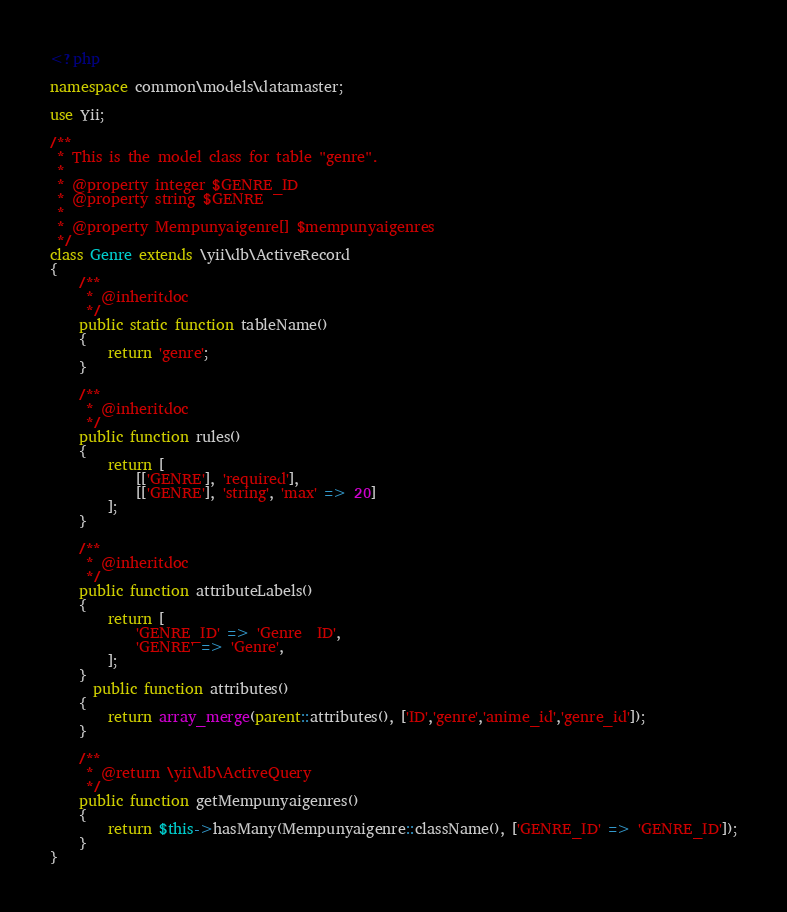Convert code to text. <code><loc_0><loc_0><loc_500><loc_500><_PHP_><?php

namespace common\models\datamaster;

use Yii;

/**
 * This is the model class for table "genre".
 *
 * @property integer $GENRE_ID
 * @property string $GENRE
 *
 * @property Mempunyaigenre[] $mempunyaigenres
 */
class Genre extends \yii\db\ActiveRecord
{
    /**
     * @inheritdoc
     */
    public static function tableName()
    {
        return 'genre';
    }

    /**
     * @inheritdoc
     */
    public function rules()
    {
        return [
            [['GENRE'], 'required'],
            [['GENRE'], 'string', 'max' => 20]
        ];
    }

    /**
     * @inheritdoc
     */
    public function attributeLabels()
    {
        return [
            'GENRE_ID' => 'Genre  ID',
            'GENRE' => 'Genre',
        ];
    }
      public function attributes()
    {
        return array_merge(parent::attributes(), ['ID','genre','anime_id','genre_id']);
    }

    /**
     * @return \yii\db\ActiveQuery
     */
    public function getMempunyaigenres()
    {
        return $this->hasMany(Mempunyaigenre::className(), ['GENRE_ID' => 'GENRE_ID']);
    }
}
</code> 